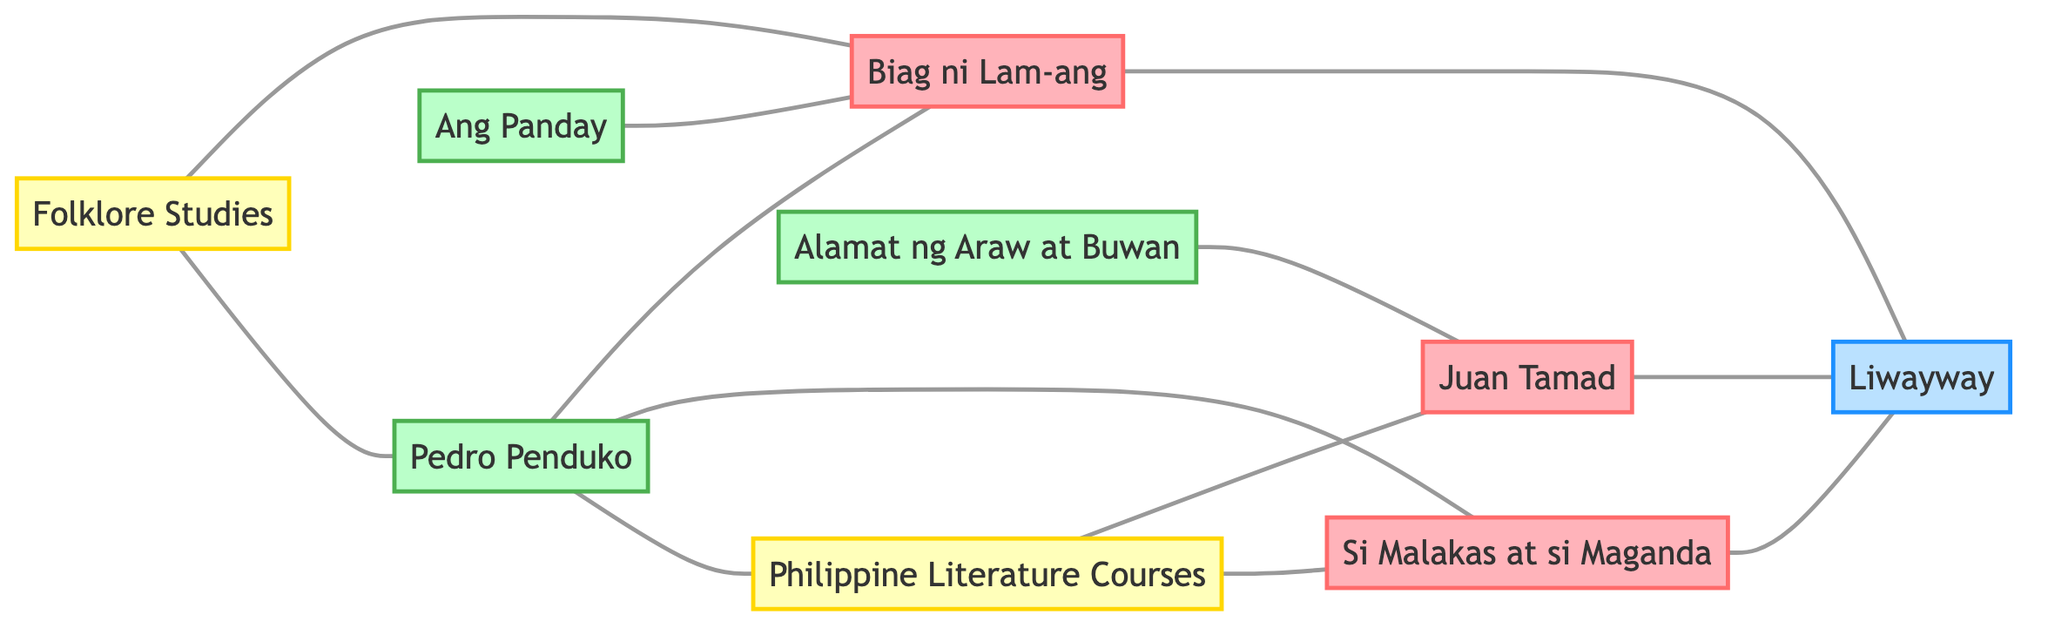What are the traditional stories represented in the diagram? The nodes labeled as "Traditional Story" are Juan Tamad, Biag ni Lam-ang, and Si Malakas at si Maganda. These nodes indicate the traditional folk tales discussed in the undirected graph.
Answer: Juan Tamad, Biag ni Lam-ang, Si Malakas at si Maganda Which modern adaptation is linked to "Biag ni Lam-ang"? By examining the edges, the node "Pedro Penduko" connects to "Biag ni Lam-ang," indicating that it is a modern adaptation linked to this traditional story.
Answer: Pedro Penduko How many nodes are categorized as modern adaptations? The nodes labeled as "Modern Adaptation" are Pedro Penduko, Alamat ng Araw at Buwan, and Ang Panday. Counting these nodes, we find there are three modern adaptations in total.
Answer: 3 Which traditional story has the most connections in terms of links to modern adaptations? Looking at the edges, "Biag ni Lam-ang" is connected to both Pedro Penduko and Ang Panday, which results in multiple edges in this category. Thus, it has the most connections compared to the other traditional stories.
Answer: Biag ni Lam-ang What is the role of "Liwayway" in the diagram? The node "Liwayway" connects with all three traditional stories, serving as a publication that features them. Hence, it is a common link between these tales, highlighting its significance in distribution or referencing.
Answer: Publication 